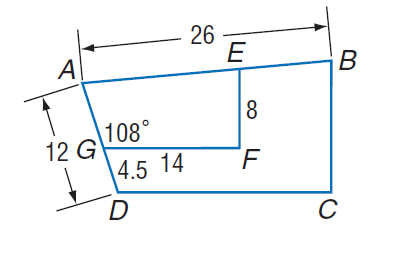Answer the mathemtical geometry problem and directly provide the correct option letter.
Question: Polygon A B C D \sim polygon A E F G, m \angle A G F = 108, G F = 14, A D = 12, D G = 4.5, E F = 8, and A B = 26. Find scale factor of trapezoid A B C D to trapezoid A E F G.
Choices: A: 1.6 B: 4.5 C: 12 D: 26 A 